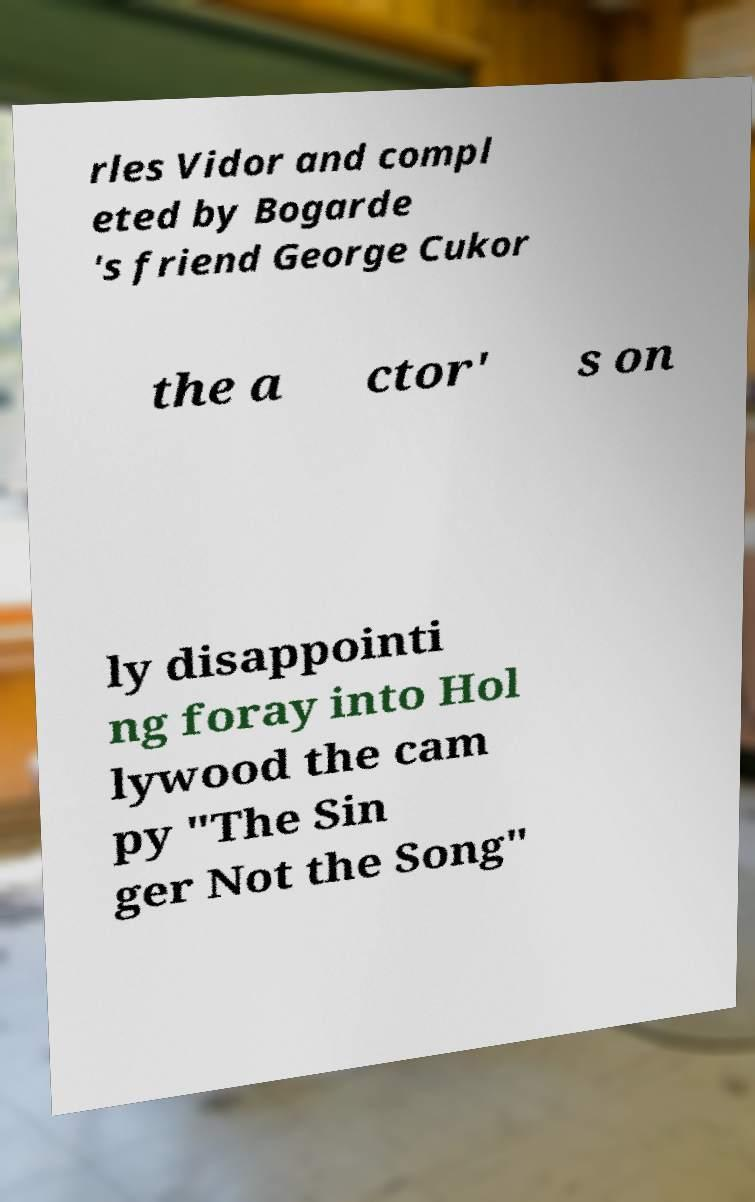Could you extract and type out the text from this image? rles Vidor and compl eted by Bogarde 's friend George Cukor the a ctor' s on ly disappointi ng foray into Hol lywood the cam py "The Sin ger Not the Song" 